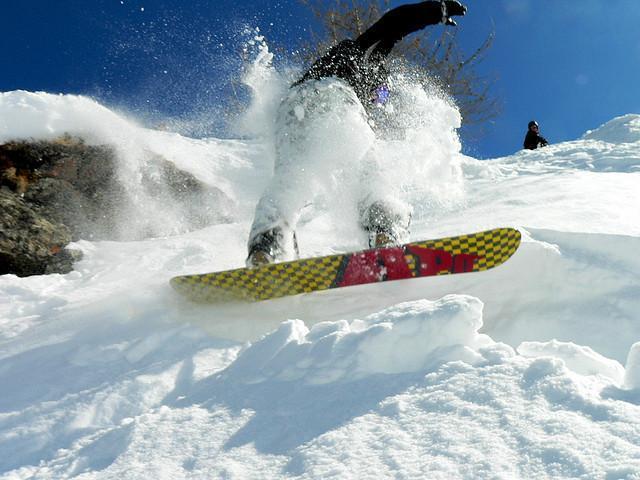How many black cups are there?
Give a very brief answer. 0. 